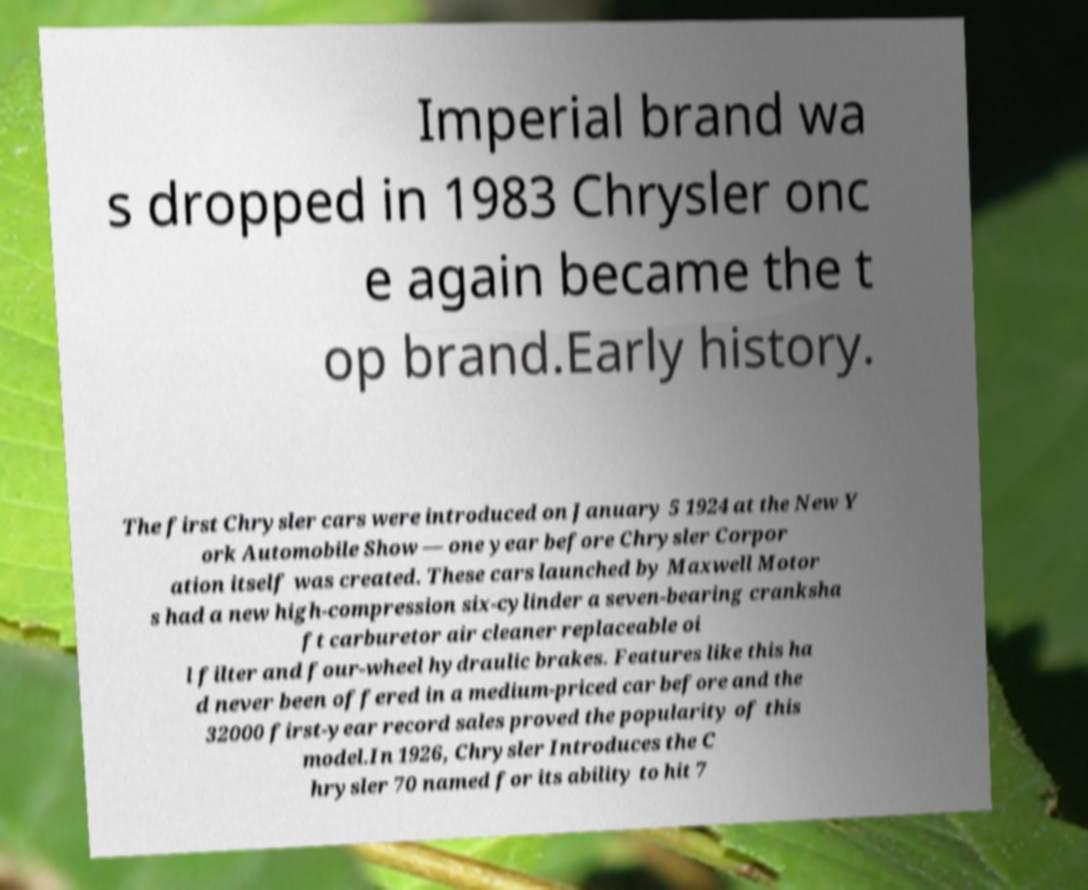There's text embedded in this image that I need extracted. Can you transcribe it verbatim? Imperial brand wa s dropped in 1983 Chrysler onc e again became the t op brand.Early history. The first Chrysler cars were introduced on January 5 1924 at the New Y ork Automobile Show — one year before Chrysler Corpor ation itself was created. These cars launched by Maxwell Motor s had a new high-compression six-cylinder a seven-bearing cranksha ft carburetor air cleaner replaceable oi l filter and four-wheel hydraulic brakes. Features like this ha d never been offered in a medium-priced car before and the 32000 first-year record sales proved the popularity of this model.In 1926, Chrysler Introduces the C hrysler 70 named for its ability to hit 7 